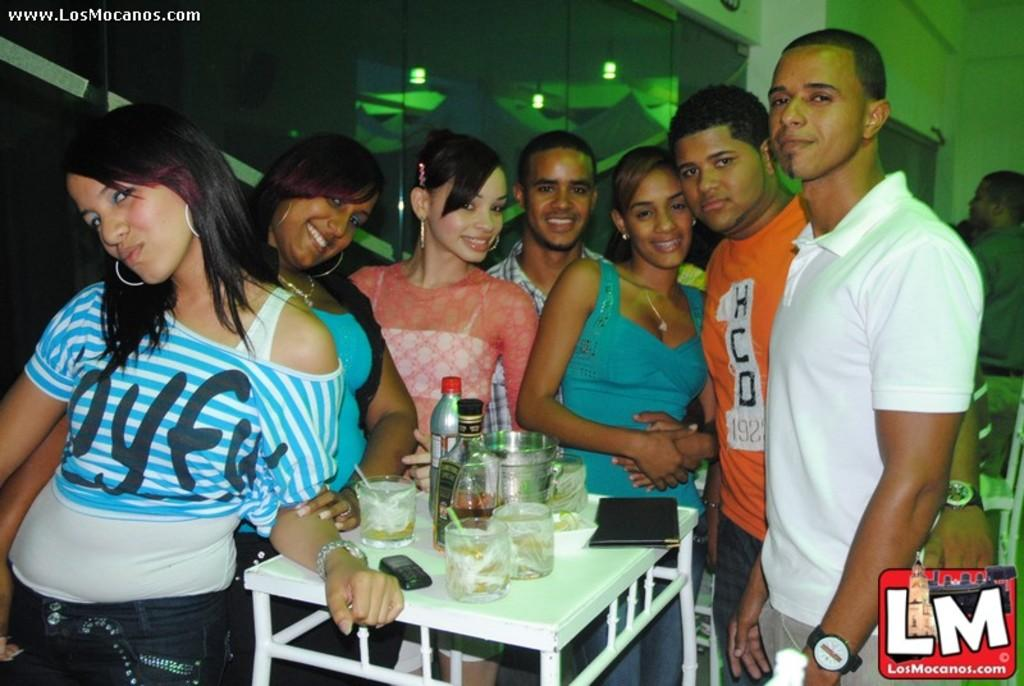What are the people in the image doing? The people in the image are standing and posing. What can be seen on the table in the image? There is a water bottle, glasses, and a wine bottle on the table. How many items are on the table in the image? There are three items on the table: a water bottle, glasses, and a wine bottle. What is the weight of the nut that is not present in the image? There is no nut present in the image, so it is not possible to determine its weight. 